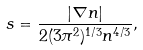Convert formula to latex. <formula><loc_0><loc_0><loc_500><loc_500>s = \frac { | \nabla n | } { 2 ( 3 \pi ^ { 2 } ) ^ { 1 / 3 } n ^ { 4 / 3 } } ,</formula> 